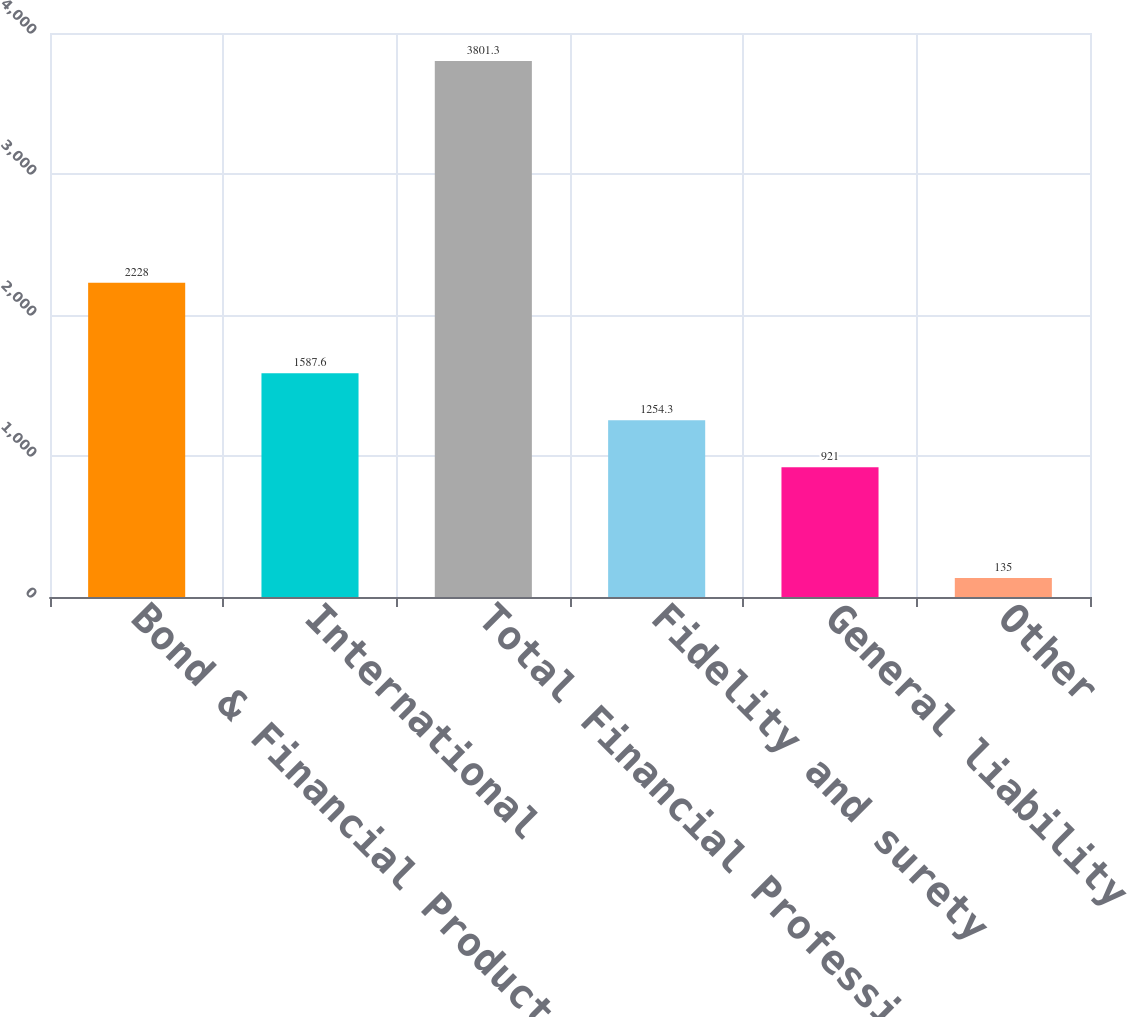Convert chart. <chart><loc_0><loc_0><loc_500><loc_500><bar_chart><fcel>Bond & Financial Products<fcel>International<fcel>Total Financial Professional &<fcel>Fidelity and surety<fcel>General liability<fcel>Other<nl><fcel>2228<fcel>1587.6<fcel>3801.3<fcel>1254.3<fcel>921<fcel>135<nl></chart> 